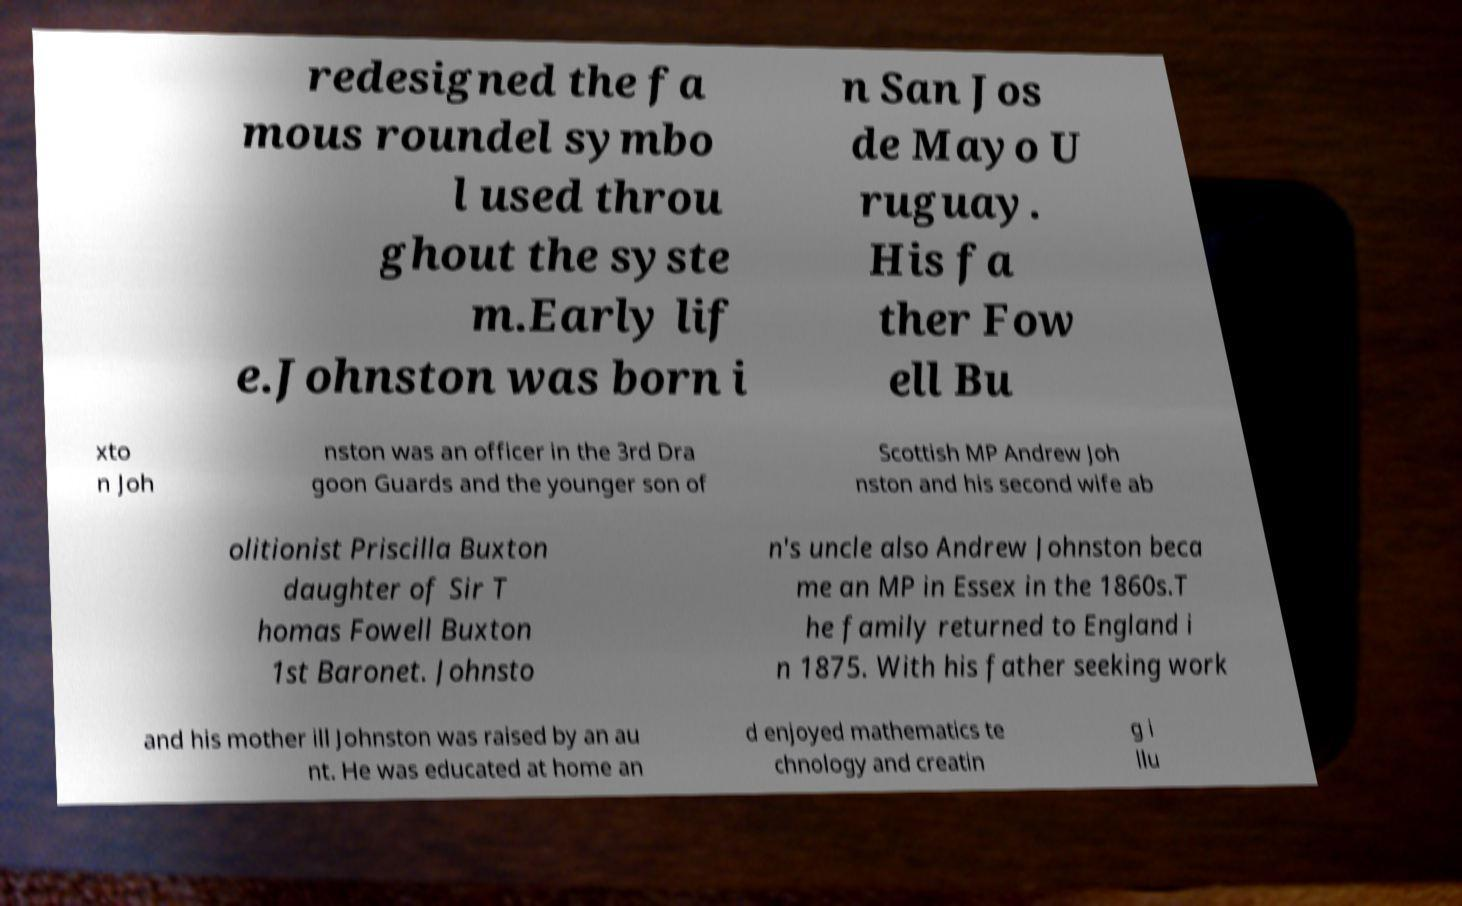I need the written content from this picture converted into text. Can you do that? redesigned the fa mous roundel symbo l used throu ghout the syste m.Early lif e.Johnston was born i n San Jos de Mayo U ruguay. His fa ther Fow ell Bu xto n Joh nston was an officer in the 3rd Dra goon Guards and the younger son of Scottish MP Andrew Joh nston and his second wife ab olitionist Priscilla Buxton daughter of Sir T homas Fowell Buxton 1st Baronet. Johnsto n's uncle also Andrew Johnston beca me an MP in Essex in the 1860s.T he family returned to England i n 1875. With his father seeking work and his mother ill Johnston was raised by an au nt. He was educated at home an d enjoyed mathematics te chnology and creatin g i llu 